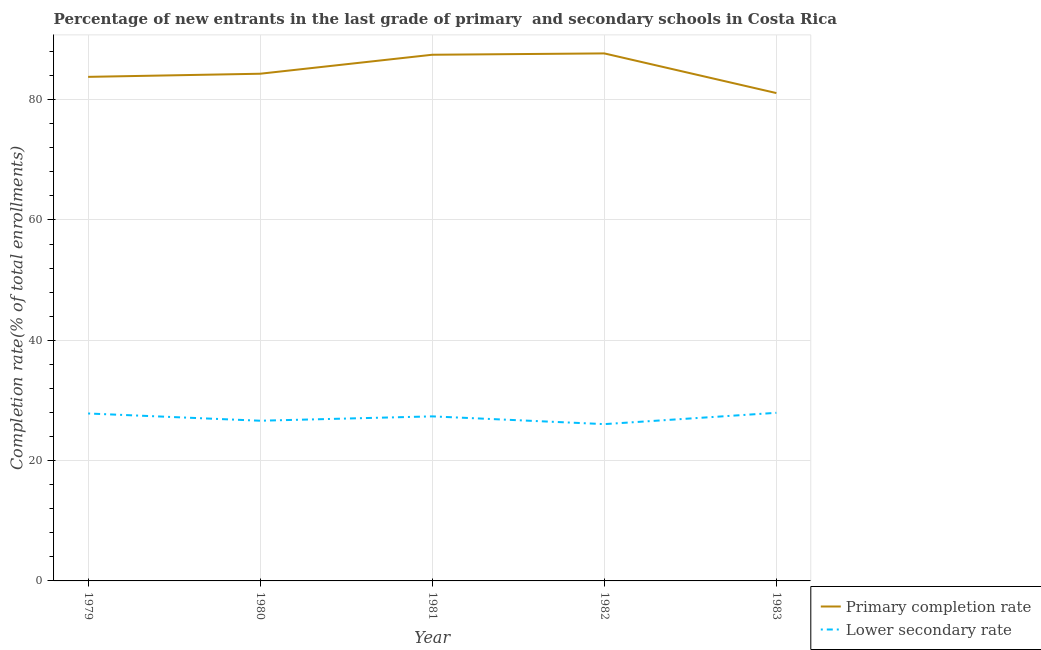How many different coloured lines are there?
Offer a terse response. 2. Is the number of lines equal to the number of legend labels?
Your response must be concise. Yes. What is the completion rate in primary schools in 1979?
Your answer should be very brief. 83.79. Across all years, what is the maximum completion rate in primary schools?
Your answer should be very brief. 87.69. Across all years, what is the minimum completion rate in secondary schools?
Ensure brevity in your answer.  26.06. In which year was the completion rate in primary schools maximum?
Keep it short and to the point. 1982. What is the total completion rate in secondary schools in the graph?
Give a very brief answer. 135.82. What is the difference between the completion rate in secondary schools in 1980 and that in 1981?
Your answer should be very brief. -0.73. What is the difference between the completion rate in secondary schools in 1980 and the completion rate in primary schools in 1979?
Your response must be concise. -57.16. What is the average completion rate in secondary schools per year?
Provide a succinct answer. 27.16. In the year 1982, what is the difference between the completion rate in primary schools and completion rate in secondary schools?
Ensure brevity in your answer.  61.62. In how many years, is the completion rate in primary schools greater than 4 %?
Ensure brevity in your answer.  5. What is the ratio of the completion rate in primary schools in 1979 to that in 1980?
Offer a terse response. 0.99. Is the completion rate in primary schools in 1980 less than that in 1982?
Provide a succinct answer. Yes. Is the difference between the completion rate in primary schools in 1979 and 1980 greater than the difference between the completion rate in secondary schools in 1979 and 1980?
Keep it short and to the point. No. What is the difference between the highest and the second highest completion rate in primary schools?
Your answer should be very brief. 0.22. What is the difference between the highest and the lowest completion rate in secondary schools?
Ensure brevity in your answer.  1.88. In how many years, is the completion rate in primary schools greater than the average completion rate in primary schools taken over all years?
Keep it short and to the point. 2. Is the sum of the completion rate in secondary schools in 1982 and 1983 greater than the maximum completion rate in primary schools across all years?
Keep it short and to the point. No. Is the completion rate in secondary schools strictly greater than the completion rate in primary schools over the years?
Your response must be concise. No. How many years are there in the graph?
Make the answer very short. 5. Are the values on the major ticks of Y-axis written in scientific E-notation?
Ensure brevity in your answer.  No. Does the graph contain grids?
Give a very brief answer. Yes. Where does the legend appear in the graph?
Offer a terse response. Bottom right. How many legend labels are there?
Your answer should be very brief. 2. How are the legend labels stacked?
Provide a short and direct response. Vertical. What is the title of the graph?
Ensure brevity in your answer.  Percentage of new entrants in the last grade of primary  and secondary schools in Costa Rica. What is the label or title of the Y-axis?
Your response must be concise. Completion rate(% of total enrollments). What is the Completion rate(% of total enrollments) in Primary completion rate in 1979?
Provide a succinct answer. 83.79. What is the Completion rate(% of total enrollments) in Lower secondary rate in 1979?
Make the answer very short. 27.83. What is the Completion rate(% of total enrollments) of Primary completion rate in 1980?
Make the answer very short. 84.31. What is the Completion rate(% of total enrollments) in Lower secondary rate in 1980?
Ensure brevity in your answer.  26.63. What is the Completion rate(% of total enrollments) in Primary completion rate in 1981?
Offer a very short reply. 87.47. What is the Completion rate(% of total enrollments) in Lower secondary rate in 1981?
Offer a terse response. 27.35. What is the Completion rate(% of total enrollments) of Primary completion rate in 1982?
Your response must be concise. 87.69. What is the Completion rate(% of total enrollments) of Lower secondary rate in 1982?
Make the answer very short. 26.06. What is the Completion rate(% of total enrollments) of Primary completion rate in 1983?
Your response must be concise. 81.1. What is the Completion rate(% of total enrollments) of Lower secondary rate in 1983?
Make the answer very short. 27.95. Across all years, what is the maximum Completion rate(% of total enrollments) in Primary completion rate?
Offer a very short reply. 87.69. Across all years, what is the maximum Completion rate(% of total enrollments) of Lower secondary rate?
Give a very brief answer. 27.95. Across all years, what is the minimum Completion rate(% of total enrollments) of Primary completion rate?
Provide a short and direct response. 81.1. Across all years, what is the minimum Completion rate(% of total enrollments) in Lower secondary rate?
Offer a terse response. 26.06. What is the total Completion rate(% of total enrollments) of Primary completion rate in the graph?
Ensure brevity in your answer.  424.35. What is the total Completion rate(% of total enrollments) of Lower secondary rate in the graph?
Give a very brief answer. 135.82. What is the difference between the Completion rate(% of total enrollments) in Primary completion rate in 1979 and that in 1980?
Ensure brevity in your answer.  -0.52. What is the difference between the Completion rate(% of total enrollments) of Lower secondary rate in 1979 and that in 1980?
Offer a terse response. 1.21. What is the difference between the Completion rate(% of total enrollments) in Primary completion rate in 1979 and that in 1981?
Your answer should be very brief. -3.68. What is the difference between the Completion rate(% of total enrollments) of Lower secondary rate in 1979 and that in 1981?
Keep it short and to the point. 0.48. What is the difference between the Completion rate(% of total enrollments) in Primary completion rate in 1979 and that in 1982?
Make the answer very short. -3.9. What is the difference between the Completion rate(% of total enrollments) in Lower secondary rate in 1979 and that in 1982?
Your response must be concise. 1.77. What is the difference between the Completion rate(% of total enrollments) in Primary completion rate in 1979 and that in 1983?
Make the answer very short. 2.69. What is the difference between the Completion rate(% of total enrollments) of Lower secondary rate in 1979 and that in 1983?
Ensure brevity in your answer.  -0.11. What is the difference between the Completion rate(% of total enrollments) of Primary completion rate in 1980 and that in 1981?
Offer a very short reply. -3.16. What is the difference between the Completion rate(% of total enrollments) in Lower secondary rate in 1980 and that in 1981?
Make the answer very short. -0.73. What is the difference between the Completion rate(% of total enrollments) in Primary completion rate in 1980 and that in 1982?
Your answer should be very brief. -3.38. What is the difference between the Completion rate(% of total enrollments) of Lower secondary rate in 1980 and that in 1982?
Your response must be concise. 0.56. What is the difference between the Completion rate(% of total enrollments) in Primary completion rate in 1980 and that in 1983?
Your response must be concise. 3.21. What is the difference between the Completion rate(% of total enrollments) in Lower secondary rate in 1980 and that in 1983?
Provide a short and direct response. -1.32. What is the difference between the Completion rate(% of total enrollments) of Primary completion rate in 1981 and that in 1982?
Give a very brief answer. -0.22. What is the difference between the Completion rate(% of total enrollments) in Lower secondary rate in 1981 and that in 1982?
Provide a short and direct response. 1.29. What is the difference between the Completion rate(% of total enrollments) of Primary completion rate in 1981 and that in 1983?
Your answer should be compact. 6.37. What is the difference between the Completion rate(% of total enrollments) in Lower secondary rate in 1981 and that in 1983?
Provide a short and direct response. -0.59. What is the difference between the Completion rate(% of total enrollments) in Primary completion rate in 1982 and that in 1983?
Give a very brief answer. 6.59. What is the difference between the Completion rate(% of total enrollments) in Lower secondary rate in 1982 and that in 1983?
Provide a succinct answer. -1.88. What is the difference between the Completion rate(% of total enrollments) of Primary completion rate in 1979 and the Completion rate(% of total enrollments) of Lower secondary rate in 1980?
Provide a succinct answer. 57.16. What is the difference between the Completion rate(% of total enrollments) in Primary completion rate in 1979 and the Completion rate(% of total enrollments) in Lower secondary rate in 1981?
Provide a succinct answer. 56.44. What is the difference between the Completion rate(% of total enrollments) in Primary completion rate in 1979 and the Completion rate(% of total enrollments) in Lower secondary rate in 1982?
Ensure brevity in your answer.  57.72. What is the difference between the Completion rate(% of total enrollments) of Primary completion rate in 1979 and the Completion rate(% of total enrollments) of Lower secondary rate in 1983?
Offer a terse response. 55.84. What is the difference between the Completion rate(% of total enrollments) of Primary completion rate in 1980 and the Completion rate(% of total enrollments) of Lower secondary rate in 1981?
Make the answer very short. 56.96. What is the difference between the Completion rate(% of total enrollments) of Primary completion rate in 1980 and the Completion rate(% of total enrollments) of Lower secondary rate in 1982?
Ensure brevity in your answer.  58.25. What is the difference between the Completion rate(% of total enrollments) in Primary completion rate in 1980 and the Completion rate(% of total enrollments) in Lower secondary rate in 1983?
Give a very brief answer. 56.37. What is the difference between the Completion rate(% of total enrollments) in Primary completion rate in 1981 and the Completion rate(% of total enrollments) in Lower secondary rate in 1982?
Offer a very short reply. 61.4. What is the difference between the Completion rate(% of total enrollments) in Primary completion rate in 1981 and the Completion rate(% of total enrollments) in Lower secondary rate in 1983?
Your response must be concise. 59.52. What is the difference between the Completion rate(% of total enrollments) in Primary completion rate in 1982 and the Completion rate(% of total enrollments) in Lower secondary rate in 1983?
Offer a terse response. 59.74. What is the average Completion rate(% of total enrollments) of Primary completion rate per year?
Offer a terse response. 84.87. What is the average Completion rate(% of total enrollments) of Lower secondary rate per year?
Provide a succinct answer. 27.16. In the year 1979, what is the difference between the Completion rate(% of total enrollments) in Primary completion rate and Completion rate(% of total enrollments) in Lower secondary rate?
Your response must be concise. 55.95. In the year 1980, what is the difference between the Completion rate(% of total enrollments) of Primary completion rate and Completion rate(% of total enrollments) of Lower secondary rate?
Ensure brevity in your answer.  57.68. In the year 1981, what is the difference between the Completion rate(% of total enrollments) of Primary completion rate and Completion rate(% of total enrollments) of Lower secondary rate?
Your answer should be very brief. 60.11. In the year 1982, what is the difference between the Completion rate(% of total enrollments) in Primary completion rate and Completion rate(% of total enrollments) in Lower secondary rate?
Your answer should be compact. 61.62. In the year 1983, what is the difference between the Completion rate(% of total enrollments) in Primary completion rate and Completion rate(% of total enrollments) in Lower secondary rate?
Provide a short and direct response. 53.15. What is the ratio of the Completion rate(% of total enrollments) in Primary completion rate in 1979 to that in 1980?
Ensure brevity in your answer.  0.99. What is the ratio of the Completion rate(% of total enrollments) in Lower secondary rate in 1979 to that in 1980?
Your answer should be compact. 1.05. What is the ratio of the Completion rate(% of total enrollments) of Primary completion rate in 1979 to that in 1981?
Give a very brief answer. 0.96. What is the ratio of the Completion rate(% of total enrollments) in Lower secondary rate in 1979 to that in 1981?
Provide a short and direct response. 1.02. What is the ratio of the Completion rate(% of total enrollments) in Primary completion rate in 1979 to that in 1982?
Offer a very short reply. 0.96. What is the ratio of the Completion rate(% of total enrollments) in Lower secondary rate in 1979 to that in 1982?
Make the answer very short. 1.07. What is the ratio of the Completion rate(% of total enrollments) of Primary completion rate in 1979 to that in 1983?
Provide a short and direct response. 1.03. What is the ratio of the Completion rate(% of total enrollments) of Primary completion rate in 1980 to that in 1981?
Your answer should be very brief. 0.96. What is the ratio of the Completion rate(% of total enrollments) in Lower secondary rate in 1980 to that in 1981?
Make the answer very short. 0.97. What is the ratio of the Completion rate(% of total enrollments) in Primary completion rate in 1980 to that in 1982?
Offer a very short reply. 0.96. What is the ratio of the Completion rate(% of total enrollments) of Lower secondary rate in 1980 to that in 1982?
Your answer should be compact. 1.02. What is the ratio of the Completion rate(% of total enrollments) of Primary completion rate in 1980 to that in 1983?
Your answer should be compact. 1.04. What is the ratio of the Completion rate(% of total enrollments) of Lower secondary rate in 1980 to that in 1983?
Ensure brevity in your answer.  0.95. What is the ratio of the Completion rate(% of total enrollments) in Primary completion rate in 1981 to that in 1982?
Give a very brief answer. 1. What is the ratio of the Completion rate(% of total enrollments) of Lower secondary rate in 1981 to that in 1982?
Your response must be concise. 1.05. What is the ratio of the Completion rate(% of total enrollments) of Primary completion rate in 1981 to that in 1983?
Your answer should be compact. 1.08. What is the ratio of the Completion rate(% of total enrollments) of Lower secondary rate in 1981 to that in 1983?
Your answer should be compact. 0.98. What is the ratio of the Completion rate(% of total enrollments) in Primary completion rate in 1982 to that in 1983?
Your answer should be compact. 1.08. What is the ratio of the Completion rate(% of total enrollments) of Lower secondary rate in 1982 to that in 1983?
Your answer should be compact. 0.93. What is the difference between the highest and the second highest Completion rate(% of total enrollments) of Primary completion rate?
Your answer should be very brief. 0.22. What is the difference between the highest and the second highest Completion rate(% of total enrollments) of Lower secondary rate?
Ensure brevity in your answer.  0.11. What is the difference between the highest and the lowest Completion rate(% of total enrollments) of Primary completion rate?
Offer a terse response. 6.59. What is the difference between the highest and the lowest Completion rate(% of total enrollments) in Lower secondary rate?
Provide a short and direct response. 1.88. 